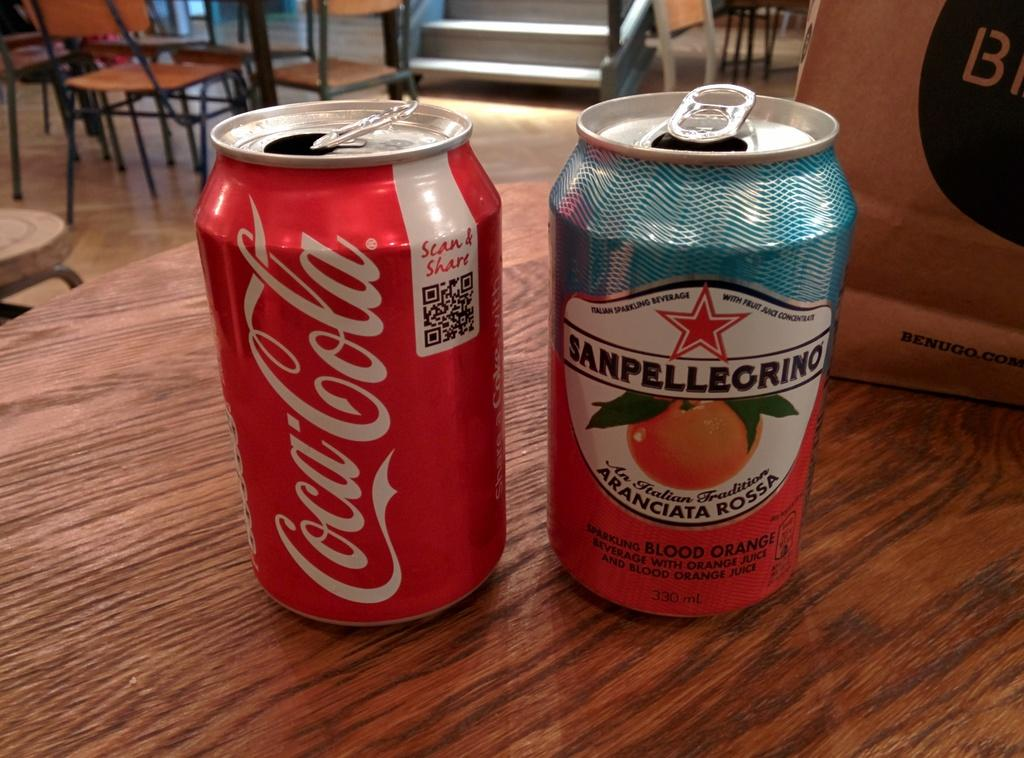Provide a one-sentence caption for the provided image. A can of Coca Cola is on a table next to another can. 